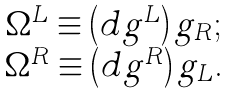<formula> <loc_0><loc_0><loc_500><loc_500>\begin{array} { c } \Omega ^ { L } \equiv \left ( d g ^ { L } \right ) g _ { R } \text {;} \\ \Omega ^ { R } \equiv \left ( d g ^ { R } \right ) g _ { L } \text {.} \end{array}</formula> 